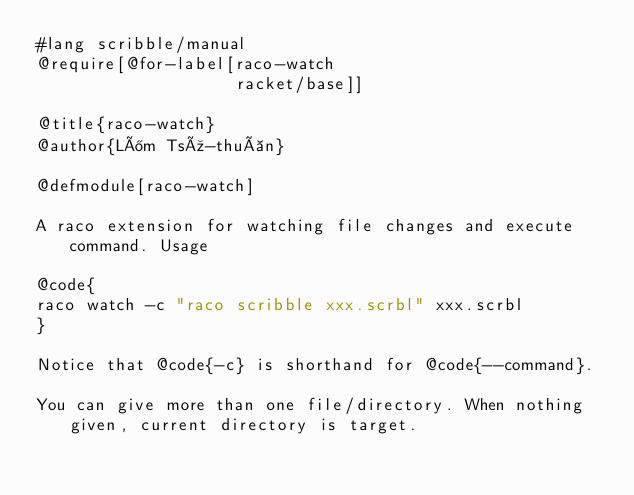Convert code to text. <code><loc_0><loc_0><loc_500><loc_500><_Racket_>#lang scribble/manual
@require[@for-label[raco-watch
                    racket/base]]

@title{raco-watch}
@author{Lîm Tsú-thuàn}

@defmodule[raco-watch]

A raco extension for watching file changes and execute command. Usage

@code{
raco watch -c "raco scribble xxx.scrbl" xxx.scrbl
}

Notice that @code{-c} is shorthand for @code{--command}.

You can give more than one file/directory. When nothing given, current directory is target.
</code> 